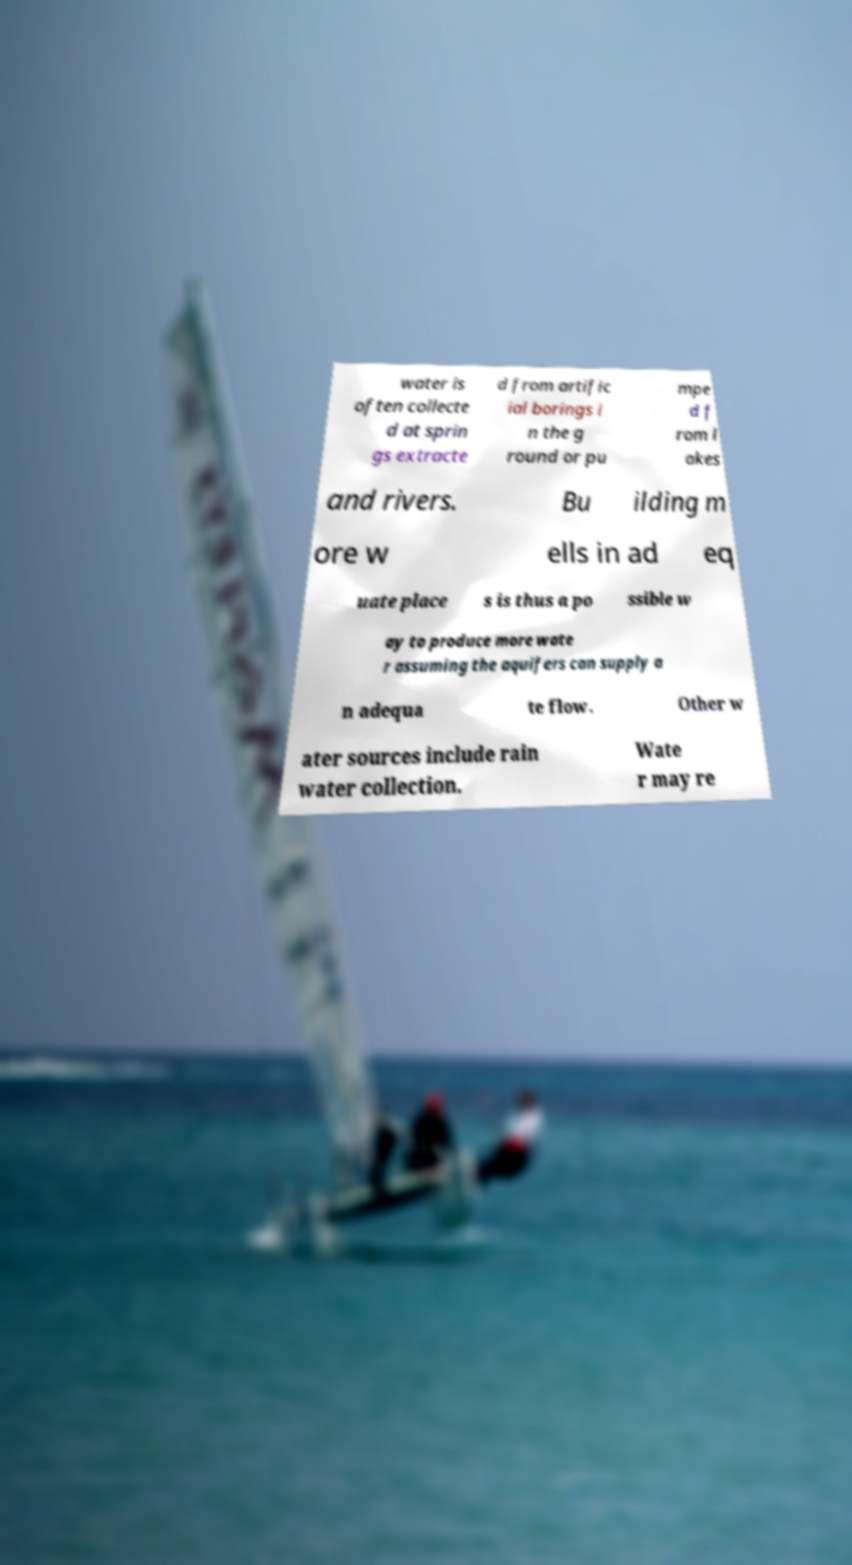Could you extract and type out the text from this image? water is often collecte d at sprin gs extracte d from artific ial borings i n the g round or pu mpe d f rom l akes and rivers. Bu ilding m ore w ells in ad eq uate place s is thus a po ssible w ay to produce more wate r assuming the aquifers can supply a n adequa te flow. Other w ater sources include rain water collection. Wate r may re 